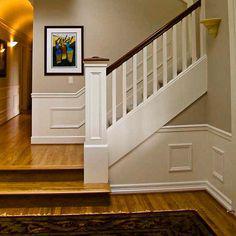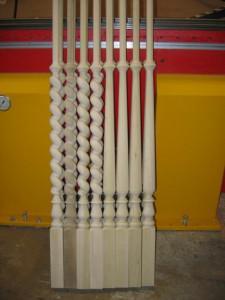The first image is the image on the left, the second image is the image on the right. Analyze the images presented: Is the assertion "The left image shows a staircase banister with dark wrought iron bars, and the right image shows a staircase with white spindles on its banister." valid? Answer yes or no. No. 